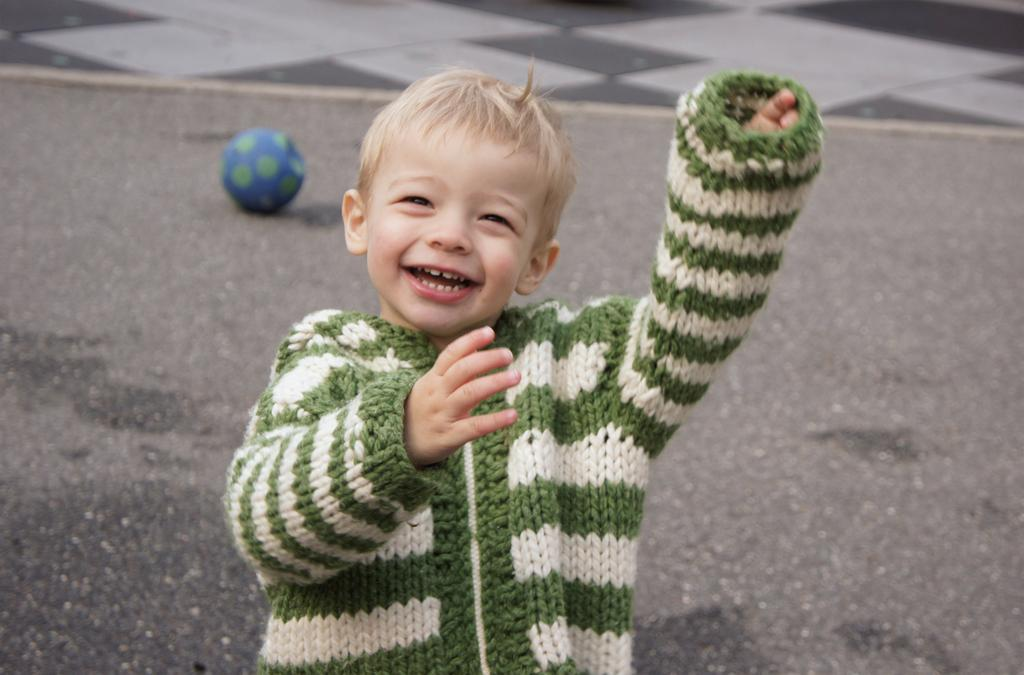What is the main subject of the image? There is a kid in the image. What can be seen in the background of the image? There is a road and a ball in the background of the image. What part of the image shows the floor? The floor is visible at the top of the image. Where is the tramp located in the image? There is no tramp present in the image. What type of duck can be seen playing with the ball in the image? There is no duck present in the image, and therefore no such activity can be observed. 